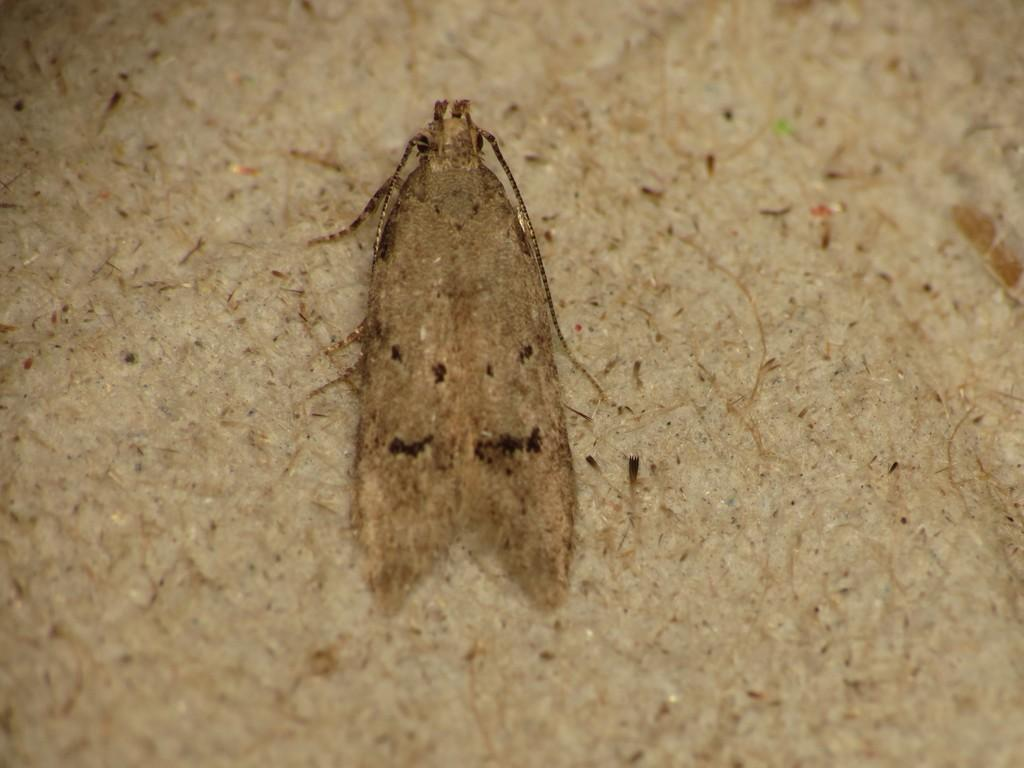What type of creature is in the image? There is an insect in the image. Where is the insect located in the image? The insect is in the center of the image. How many cakes are being shared by the children on the land in the image? There are no cakes, children, or land present in the image; it only features an insect. 